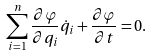Convert formula to latex. <formula><loc_0><loc_0><loc_500><loc_500>\sum _ { i = 1 } ^ { n } \frac { \partial \varphi } { \partial q _ { i } } \dot { q } _ { i } + \frac { \partial \varphi } { \partial t } = 0 { . }</formula> 